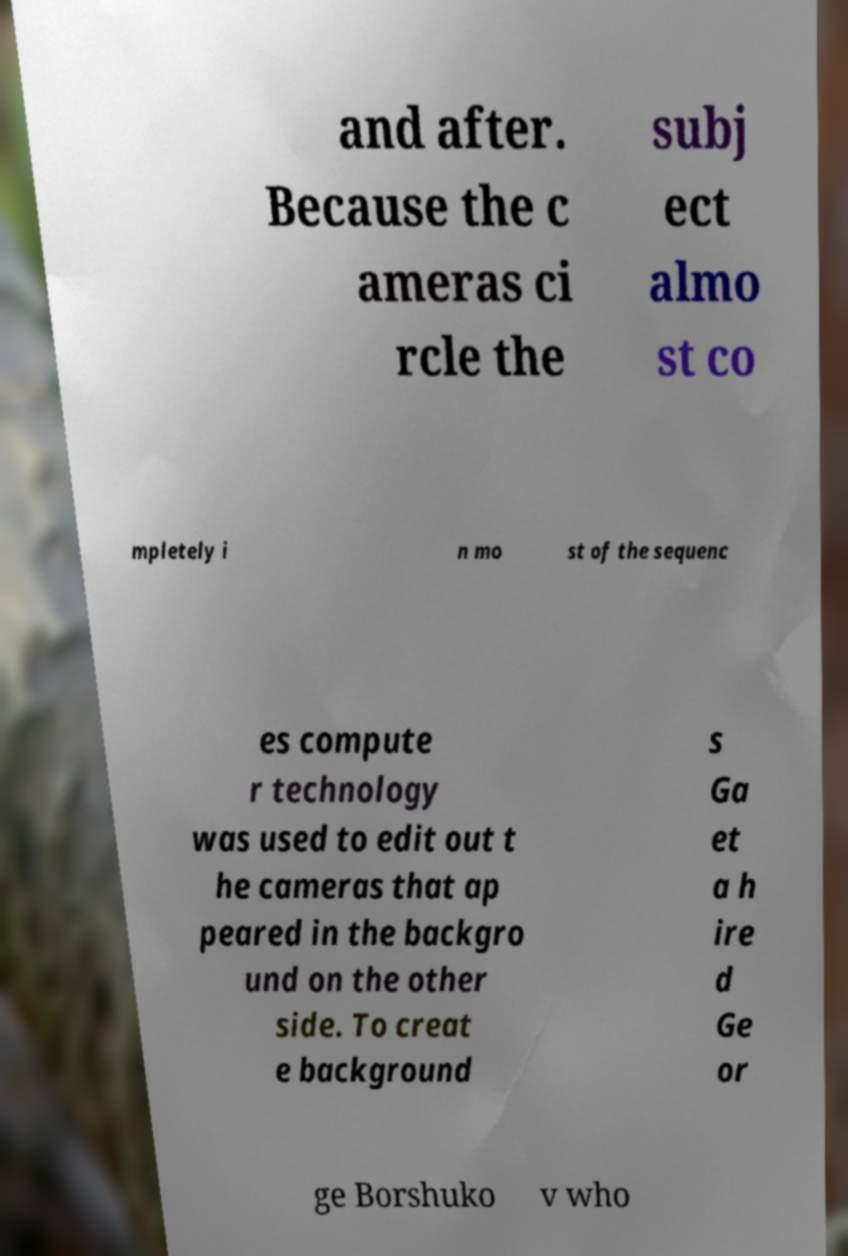Could you extract and type out the text from this image? and after. Because the c ameras ci rcle the subj ect almo st co mpletely i n mo st of the sequenc es compute r technology was used to edit out t he cameras that ap peared in the backgro und on the other side. To creat e background s Ga et a h ire d Ge or ge Borshuko v who 